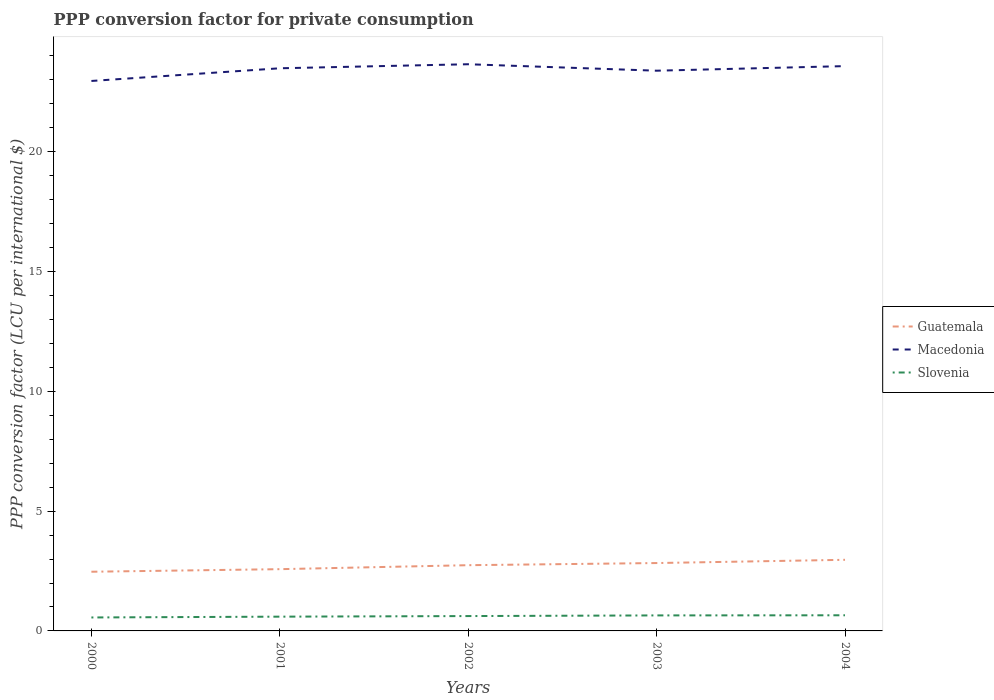How many different coloured lines are there?
Your answer should be compact. 3. Across all years, what is the maximum PPP conversion factor for private consumption in Slovenia?
Ensure brevity in your answer.  0.56. In which year was the PPP conversion factor for private consumption in Macedonia maximum?
Offer a terse response. 2000. What is the total PPP conversion factor for private consumption in Slovenia in the graph?
Make the answer very short. -0.01. What is the difference between the highest and the second highest PPP conversion factor for private consumption in Slovenia?
Give a very brief answer. 0.09. How many years are there in the graph?
Make the answer very short. 5. Are the values on the major ticks of Y-axis written in scientific E-notation?
Provide a short and direct response. No. What is the title of the graph?
Give a very brief answer. PPP conversion factor for private consumption. What is the label or title of the Y-axis?
Provide a short and direct response. PPP conversion factor (LCU per international $). What is the PPP conversion factor (LCU per international $) in Guatemala in 2000?
Your response must be concise. 2.47. What is the PPP conversion factor (LCU per international $) in Macedonia in 2000?
Ensure brevity in your answer.  22.95. What is the PPP conversion factor (LCU per international $) in Slovenia in 2000?
Provide a short and direct response. 0.56. What is the PPP conversion factor (LCU per international $) of Guatemala in 2001?
Your response must be concise. 2.58. What is the PPP conversion factor (LCU per international $) in Macedonia in 2001?
Your answer should be compact. 23.48. What is the PPP conversion factor (LCU per international $) in Slovenia in 2001?
Ensure brevity in your answer.  0.6. What is the PPP conversion factor (LCU per international $) in Guatemala in 2002?
Make the answer very short. 2.74. What is the PPP conversion factor (LCU per international $) in Macedonia in 2002?
Offer a very short reply. 23.65. What is the PPP conversion factor (LCU per international $) in Slovenia in 2002?
Ensure brevity in your answer.  0.62. What is the PPP conversion factor (LCU per international $) in Guatemala in 2003?
Your answer should be very brief. 2.83. What is the PPP conversion factor (LCU per international $) in Macedonia in 2003?
Give a very brief answer. 23.38. What is the PPP conversion factor (LCU per international $) in Slovenia in 2003?
Your answer should be very brief. 0.65. What is the PPP conversion factor (LCU per international $) in Guatemala in 2004?
Keep it short and to the point. 2.97. What is the PPP conversion factor (LCU per international $) in Macedonia in 2004?
Offer a terse response. 23.57. What is the PPP conversion factor (LCU per international $) of Slovenia in 2004?
Your answer should be very brief. 0.65. Across all years, what is the maximum PPP conversion factor (LCU per international $) in Guatemala?
Your answer should be very brief. 2.97. Across all years, what is the maximum PPP conversion factor (LCU per international $) of Macedonia?
Offer a very short reply. 23.65. Across all years, what is the maximum PPP conversion factor (LCU per international $) in Slovenia?
Offer a terse response. 0.65. Across all years, what is the minimum PPP conversion factor (LCU per international $) of Guatemala?
Provide a short and direct response. 2.47. Across all years, what is the minimum PPP conversion factor (LCU per international $) of Macedonia?
Your response must be concise. 22.95. Across all years, what is the minimum PPP conversion factor (LCU per international $) in Slovenia?
Provide a short and direct response. 0.56. What is the total PPP conversion factor (LCU per international $) in Guatemala in the graph?
Ensure brevity in your answer.  13.59. What is the total PPP conversion factor (LCU per international $) in Macedonia in the graph?
Provide a short and direct response. 117.04. What is the total PPP conversion factor (LCU per international $) in Slovenia in the graph?
Your answer should be very brief. 3.08. What is the difference between the PPP conversion factor (LCU per international $) in Guatemala in 2000 and that in 2001?
Provide a short and direct response. -0.11. What is the difference between the PPP conversion factor (LCU per international $) of Macedonia in 2000 and that in 2001?
Your answer should be very brief. -0.53. What is the difference between the PPP conversion factor (LCU per international $) of Slovenia in 2000 and that in 2001?
Provide a succinct answer. -0.03. What is the difference between the PPP conversion factor (LCU per international $) of Guatemala in 2000 and that in 2002?
Your response must be concise. -0.27. What is the difference between the PPP conversion factor (LCU per international $) in Macedonia in 2000 and that in 2002?
Offer a terse response. -0.7. What is the difference between the PPP conversion factor (LCU per international $) in Slovenia in 2000 and that in 2002?
Provide a succinct answer. -0.06. What is the difference between the PPP conversion factor (LCU per international $) in Guatemala in 2000 and that in 2003?
Keep it short and to the point. -0.36. What is the difference between the PPP conversion factor (LCU per international $) of Macedonia in 2000 and that in 2003?
Your answer should be compact. -0.43. What is the difference between the PPP conversion factor (LCU per international $) of Slovenia in 2000 and that in 2003?
Your response must be concise. -0.09. What is the difference between the PPP conversion factor (LCU per international $) of Guatemala in 2000 and that in 2004?
Provide a succinct answer. -0.5. What is the difference between the PPP conversion factor (LCU per international $) in Macedonia in 2000 and that in 2004?
Keep it short and to the point. -0.62. What is the difference between the PPP conversion factor (LCU per international $) of Slovenia in 2000 and that in 2004?
Provide a succinct answer. -0.09. What is the difference between the PPP conversion factor (LCU per international $) of Guatemala in 2001 and that in 2002?
Provide a succinct answer. -0.17. What is the difference between the PPP conversion factor (LCU per international $) of Macedonia in 2001 and that in 2002?
Your answer should be compact. -0.17. What is the difference between the PPP conversion factor (LCU per international $) in Slovenia in 2001 and that in 2002?
Your answer should be very brief. -0.02. What is the difference between the PPP conversion factor (LCU per international $) of Guatemala in 2001 and that in 2003?
Give a very brief answer. -0.26. What is the difference between the PPP conversion factor (LCU per international $) in Macedonia in 2001 and that in 2003?
Provide a succinct answer. 0.1. What is the difference between the PPP conversion factor (LCU per international $) of Slovenia in 2001 and that in 2003?
Keep it short and to the point. -0.05. What is the difference between the PPP conversion factor (LCU per international $) of Guatemala in 2001 and that in 2004?
Ensure brevity in your answer.  -0.39. What is the difference between the PPP conversion factor (LCU per international $) of Macedonia in 2001 and that in 2004?
Make the answer very short. -0.09. What is the difference between the PPP conversion factor (LCU per international $) in Slovenia in 2001 and that in 2004?
Make the answer very short. -0.06. What is the difference between the PPP conversion factor (LCU per international $) in Guatemala in 2002 and that in 2003?
Ensure brevity in your answer.  -0.09. What is the difference between the PPP conversion factor (LCU per international $) of Macedonia in 2002 and that in 2003?
Your response must be concise. 0.27. What is the difference between the PPP conversion factor (LCU per international $) of Slovenia in 2002 and that in 2003?
Ensure brevity in your answer.  -0.03. What is the difference between the PPP conversion factor (LCU per international $) in Guatemala in 2002 and that in 2004?
Your answer should be compact. -0.22. What is the difference between the PPP conversion factor (LCU per international $) in Macedonia in 2002 and that in 2004?
Make the answer very short. 0.08. What is the difference between the PPP conversion factor (LCU per international $) of Slovenia in 2002 and that in 2004?
Give a very brief answer. -0.03. What is the difference between the PPP conversion factor (LCU per international $) in Guatemala in 2003 and that in 2004?
Ensure brevity in your answer.  -0.14. What is the difference between the PPP conversion factor (LCU per international $) in Macedonia in 2003 and that in 2004?
Provide a short and direct response. -0.19. What is the difference between the PPP conversion factor (LCU per international $) in Slovenia in 2003 and that in 2004?
Ensure brevity in your answer.  -0.01. What is the difference between the PPP conversion factor (LCU per international $) of Guatemala in 2000 and the PPP conversion factor (LCU per international $) of Macedonia in 2001?
Provide a short and direct response. -21.01. What is the difference between the PPP conversion factor (LCU per international $) in Guatemala in 2000 and the PPP conversion factor (LCU per international $) in Slovenia in 2001?
Your response must be concise. 1.87. What is the difference between the PPP conversion factor (LCU per international $) of Macedonia in 2000 and the PPP conversion factor (LCU per international $) of Slovenia in 2001?
Offer a terse response. 22.36. What is the difference between the PPP conversion factor (LCU per international $) of Guatemala in 2000 and the PPP conversion factor (LCU per international $) of Macedonia in 2002?
Give a very brief answer. -21.18. What is the difference between the PPP conversion factor (LCU per international $) of Guatemala in 2000 and the PPP conversion factor (LCU per international $) of Slovenia in 2002?
Make the answer very short. 1.85. What is the difference between the PPP conversion factor (LCU per international $) of Macedonia in 2000 and the PPP conversion factor (LCU per international $) of Slovenia in 2002?
Keep it short and to the point. 22.33. What is the difference between the PPP conversion factor (LCU per international $) in Guatemala in 2000 and the PPP conversion factor (LCU per international $) in Macedonia in 2003?
Provide a succinct answer. -20.91. What is the difference between the PPP conversion factor (LCU per international $) of Guatemala in 2000 and the PPP conversion factor (LCU per international $) of Slovenia in 2003?
Your answer should be compact. 1.82. What is the difference between the PPP conversion factor (LCU per international $) in Macedonia in 2000 and the PPP conversion factor (LCU per international $) in Slovenia in 2003?
Offer a very short reply. 22.31. What is the difference between the PPP conversion factor (LCU per international $) in Guatemala in 2000 and the PPP conversion factor (LCU per international $) in Macedonia in 2004?
Give a very brief answer. -21.1. What is the difference between the PPP conversion factor (LCU per international $) of Guatemala in 2000 and the PPP conversion factor (LCU per international $) of Slovenia in 2004?
Provide a short and direct response. 1.82. What is the difference between the PPP conversion factor (LCU per international $) in Macedonia in 2000 and the PPP conversion factor (LCU per international $) in Slovenia in 2004?
Ensure brevity in your answer.  22.3. What is the difference between the PPP conversion factor (LCU per international $) of Guatemala in 2001 and the PPP conversion factor (LCU per international $) of Macedonia in 2002?
Provide a short and direct response. -21.07. What is the difference between the PPP conversion factor (LCU per international $) in Guatemala in 2001 and the PPP conversion factor (LCU per international $) in Slovenia in 2002?
Provide a short and direct response. 1.96. What is the difference between the PPP conversion factor (LCU per international $) in Macedonia in 2001 and the PPP conversion factor (LCU per international $) in Slovenia in 2002?
Your response must be concise. 22.86. What is the difference between the PPP conversion factor (LCU per international $) of Guatemala in 2001 and the PPP conversion factor (LCU per international $) of Macedonia in 2003?
Give a very brief answer. -20.8. What is the difference between the PPP conversion factor (LCU per international $) in Guatemala in 2001 and the PPP conversion factor (LCU per international $) in Slovenia in 2003?
Ensure brevity in your answer.  1.93. What is the difference between the PPP conversion factor (LCU per international $) in Macedonia in 2001 and the PPP conversion factor (LCU per international $) in Slovenia in 2003?
Give a very brief answer. 22.84. What is the difference between the PPP conversion factor (LCU per international $) of Guatemala in 2001 and the PPP conversion factor (LCU per international $) of Macedonia in 2004?
Your answer should be compact. -21. What is the difference between the PPP conversion factor (LCU per international $) of Guatemala in 2001 and the PPP conversion factor (LCU per international $) of Slovenia in 2004?
Keep it short and to the point. 1.92. What is the difference between the PPP conversion factor (LCU per international $) of Macedonia in 2001 and the PPP conversion factor (LCU per international $) of Slovenia in 2004?
Give a very brief answer. 22.83. What is the difference between the PPP conversion factor (LCU per international $) of Guatemala in 2002 and the PPP conversion factor (LCU per international $) of Macedonia in 2003?
Your response must be concise. -20.64. What is the difference between the PPP conversion factor (LCU per international $) in Guatemala in 2002 and the PPP conversion factor (LCU per international $) in Slovenia in 2003?
Keep it short and to the point. 2.1. What is the difference between the PPP conversion factor (LCU per international $) of Macedonia in 2002 and the PPP conversion factor (LCU per international $) of Slovenia in 2003?
Give a very brief answer. 23. What is the difference between the PPP conversion factor (LCU per international $) in Guatemala in 2002 and the PPP conversion factor (LCU per international $) in Macedonia in 2004?
Provide a succinct answer. -20.83. What is the difference between the PPP conversion factor (LCU per international $) in Guatemala in 2002 and the PPP conversion factor (LCU per international $) in Slovenia in 2004?
Ensure brevity in your answer.  2.09. What is the difference between the PPP conversion factor (LCU per international $) of Macedonia in 2002 and the PPP conversion factor (LCU per international $) of Slovenia in 2004?
Make the answer very short. 23. What is the difference between the PPP conversion factor (LCU per international $) in Guatemala in 2003 and the PPP conversion factor (LCU per international $) in Macedonia in 2004?
Ensure brevity in your answer.  -20.74. What is the difference between the PPP conversion factor (LCU per international $) of Guatemala in 2003 and the PPP conversion factor (LCU per international $) of Slovenia in 2004?
Ensure brevity in your answer.  2.18. What is the difference between the PPP conversion factor (LCU per international $) in Macedonia in 2003 and the PPP conversion factor (LCU per international $) in Slovenia in 2004?
Your answer should be compact. 22.73. What is the average PPP conversion factor (LCU per international $) in Guatemala per year?
Give a very brief answer. 2.72. What is the average PPP conversion factor (LCU per international $) in Macedonia per year?
Offer a very short reply. 23.41. What is the average PPP conversion factor (LCU per international $) of Slovenia per year?
Offer a terse response. 0.62. In the year 2000, what is the difference between the PPP conversion factor (LCU per international $) in Guatemala and PPP conversion factor (LCU per international $) in Macedonia?
Offer a very short reply. -20.48. In the year 2000, what is the difference between the PPP conversion factor (LCU per international $) in Guatemala and PPP conversion factor (LCU per international $) in Slovenia?
Provide a succinct answer. 1.91. In the year 2000, what is the difference between the PPP conversion factor (LCU per international $) in Macedonia and PPP conversion factor (LCU per international $) in Slovenia?
Your response must be concise. 22.39. In the year 2001, what is the difference between the PPP conversion factor (LCU per international $) in Guatemala and PPP conversion factor (LCU per international $) in Macedonia?
Your response must be concise. -20.91. In the year 2001, what is the difference between the PPP conversion factor (LCU per international $) of Guatemala and PPP conversion factor (LCU per international $) of Slovenia?
Provide a succinct answer. 1.98. In the year 2001, what is the difference between the PPP conversion factor (LCU per international $) of Macedonia and PPP conversion factor (LCU per international $) of Slovenia?
Give a very brief answer. 22.89. In the year 2002, what is the difference between the PPP conversion factor (LCU per international $) in Guatemala and PPP conversion factor (LCU per international $) in Macedonia?
Your answer should be compact. -20.91. In the year 2002, what is the difference between the PPP conversion factor (LCU per international $) in Guatemala and PPP conversion factor (LCU per international $) in Slovenia?
Your answer should be compact. 2.12. In the year 2002, what is the difference between the PPP conversion factor (LCU per international $) of Macedonia and PPP conversion factor (LCU per international $) of Slovenia?
Make the answer very short. 23.03. In the year 2003, what is the difference between the PPP conversion factor (LCU per international $) of Guatemala and PPP conversion factor (LCU per international $) of Macedonia?
Ensure brevity in your answer.  -20.55. In the year 2003, what is the difference between the PPP conversion factor (LCU per international $) of Guatemala and PPP conversion factor (LCU per international $) of Slovenia?
Offer a very short reply. 2.19. In the year 2003, what is the difference between the PPP conversion factor (LCU per international $) in Macedonia and PPP conversion factor (LCU per international $) in Slovenia?
Provide a succinct answer. 22.73. In the year 2004, what is the difference between the PPP conversion factor (LCU per international $) of Guatemala and PPP conversion factor (LCU per international $) of Macedonia?
Provide a succinct answer. -20.61. In the year 2004, what is the difference between the PPP conversion factor (LCU per international $) in Guatemala and PPP conversion factor (LCU per international $) in Slovenia?
Offer a terse response. 2.32. In the year 2004, what is the difference between the PPP conversion factor (LCU per international $) in Macedonia and PPP conversion factor (LCU per international $) in Slovenia?
Offer a very short reply. 22.92. What is the ratio of the PPP conversion factor (LCU per international $) in Guatemala in 2000 to that in 2001?
Provide a succinct answer. 0.96. What is the ratio of the PPP conversion factor (LCU per international $) in Macedonia in 2000 to that in 2001?
Make the answer very short. 0.98. What is the ratio of the PPP conversion factor (LCU per international $) in Slovenia in 2000 to that in 2001?
Your answer should be very brief. 0.94. What is the ratio of the PPP conversion factor (LCU per international $) of Guatemala in 2000 to that in 2002?
Give a very brief answer. 0.9. What is the ratio of the PPP conversion factor (LCU per international $) in Macedonia in 2000 to that in 2002?
Your response must be concise. 0.97. What is the ratio of the PPP conversion factor (LCU per international $) of Slovenia in 2000 to that in 2002?
Your response must be concise. 0.91. What is the ratio of the PPP conversion factor (LCU per international $) of Guatemala in 2000 to that in 2003?
Offer a terse response. 0.87. What is the ratio of the PPP conversion factor (LCU per international $) of Macedonia in 2000 to that in 2003?
Give a very brief answer. 0.98. What is the ratio of the PPP conversion factor (LCU per international $) in Slovenia in 2000 to that in 2003?
Keep it short and to the point. 0.87. What is the ratio of the PPP conversion factor (LCU per international $) of Guatemala in 2000 to that in 2004?
Your answer should be compact. 0.83. What is the ratio of the PPP conversion factor (LCU per international $) in Macedonia in 2000 to that in 2004?
Give a very brief answer. 0.97. What is the ratio of the PPP conversion factor (LCU per international $) of Slovenia in 2000 to that in 2004?
Your answer should be compact. 0.86. What is the ratio of the PPP conversion factor (LCU per international $) in Guatemala in 2001 to that in 2002?
Ensure brevity in your answer.  0.94. What is the ratio of the PPP conversion factor (LCU per international $) in Slovenia in 2001 to that in 2002?
Give a very brief answer. 0.96. What is the ratio of the PPP conversion factor (LCU per international $) in Guatemala in 2001 to that in 2003?
Ensure brevity in your answer.  0.91. What is the ratio of the PPP conversion factor (LCU per international $) of Macedonia in 2001 to that in 2003?
Offer a terse response. 1. What is the ratio of the PPP conversion factor (LCU per international $) of Slovenia in 2001 to that in 2003?
Your response must be concise. 0.92. What is the ratio of the PPP conversion factor (LCU per international $) of Guatemala in 2001 to that in 2004?
Your answer should be very brief. 0.87. What is the ratio of the PPP conversion factor (LCU per international $) of Slovenia in 2001 to that in 2004?
Provide a short and direct response. 0.91. What is the ratio of the PPP conversion factor (LCU per international $) in Guatemala in 2002 to that in 2003?
Provide a short and direct response. 0.97. What is the ratio of the PPP conversion factor (LCU per international $) in Macedonia in 2002 to that in 2003?
Ensure brevity in your answer.  1.01. What is the ratio of the PPP conversion factor (LCU per international $) of Slovenia in 2002 to that in 2003?
Your response must be concise. 0.96. What is the ratio of the PPP conversion factor (LCU per international $) in Guatemala in 2002 to that in 2004?
Offer a very short reply. 0.92. What is the ratio of the PPP conversion factor (LCU per international $) in Slovenia in 2002 to that in 2004?
Your answer should be compact. 0.95. What is the ratio of the PPP conversion factor (LCU per international $) in Guatemala in 2003 to that in 2004?
Provide a short and direct response. 0.95. What is the ratio of the PPP conversion factor (LCU per international $) of Macedonia in 2003 to that in 2004?
Offer a terse response. 0.99. What is the difference between the highest and the second highest PPP conversion factor (LCU per international $) in Guatemala?
Make the answer very short. 0.14. What is the difference between the highest and the second highest PPP conversion factor (LCU per international $) of Macedonia?
Offer a very short reply. 0.08. What is the difference between the highest and the second highest PPP conversion factor (LCU per international $) in Slovenia?
Provide a short and direct response. 0.01. What is the difference between the highest and the lowest PPP conversion factor (LCU per international $) of Guatemala?
Offer a terse response. 0.5. What is the difference between the highest and the lowest PPP conversion factor (LCU per international $) in Macedonia?
Offer a very short reply. 0.7. What is the difference between the highest and the lowest PPP conversion factor (LCU per international $) of Slovenia?
Your response must be concise. 0.09. 